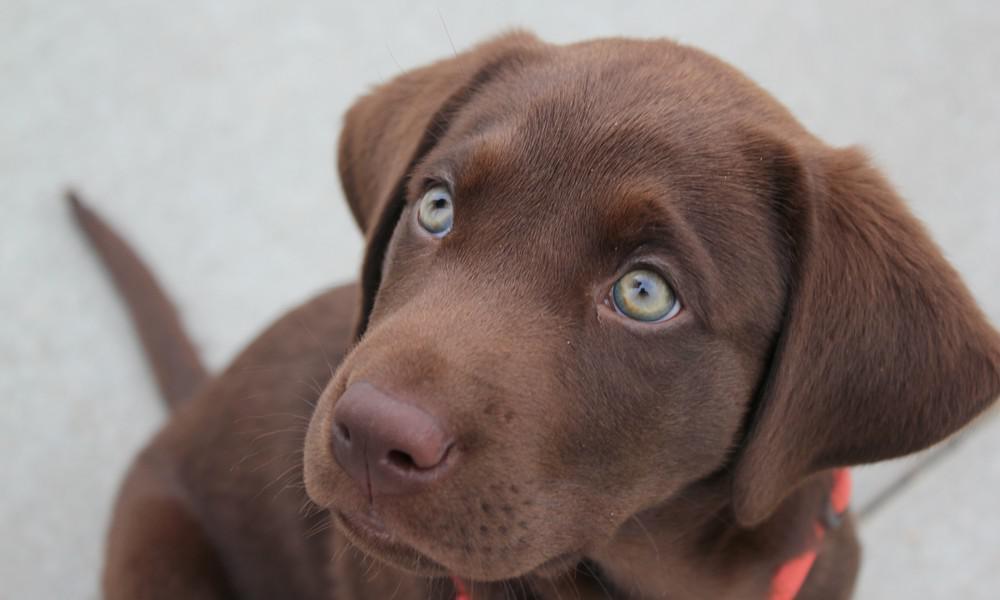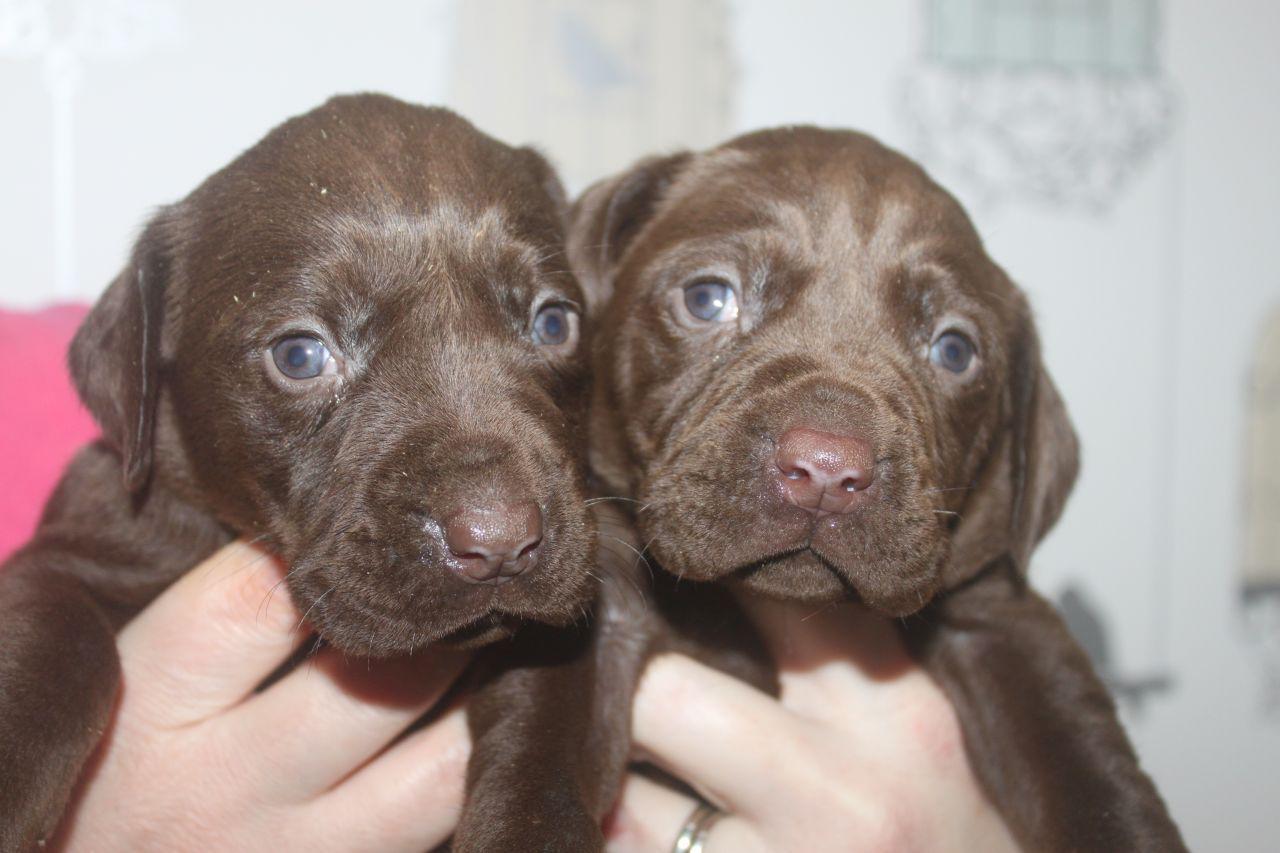The first image is the image on the left, the second image is the image on the right. For the images displayed, is the sentence "The right image contains one dog with its tongue hanging out." factually correct? Answer yes or no. No. The first image is the image on the left, the second image is the image on the right. Evaluate the accuracy of this statement regarding the images: "Each image contains exactly one dog, all dogs have grey fur, and one dog has its tongue hanging out.". Is it true? Answer yes or no. No. 